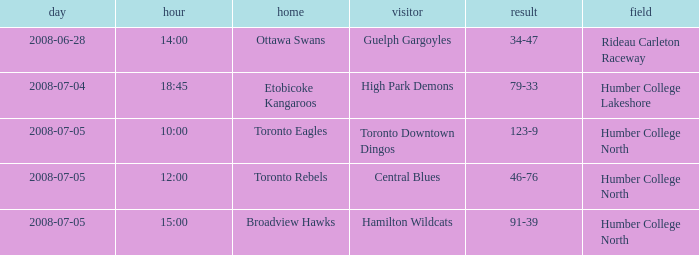What is the Score with a Date that is 2008-06-28? 34-47. 